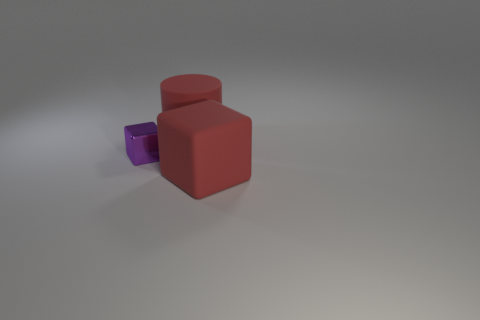Add 3 big yellow metallic things. How many objects exist? 6 Subtract all cubes. How many objects are left? 1 Subtract 0 gray cylinders. How many objects are left? 3 Subtract all cylinders. Subtract all big red blocks. How many objects are left? 1 Add 1 matte objects. How many matte objects are left? 3 Add 3 rubber blocks. How many rubber blocks exist? 4 